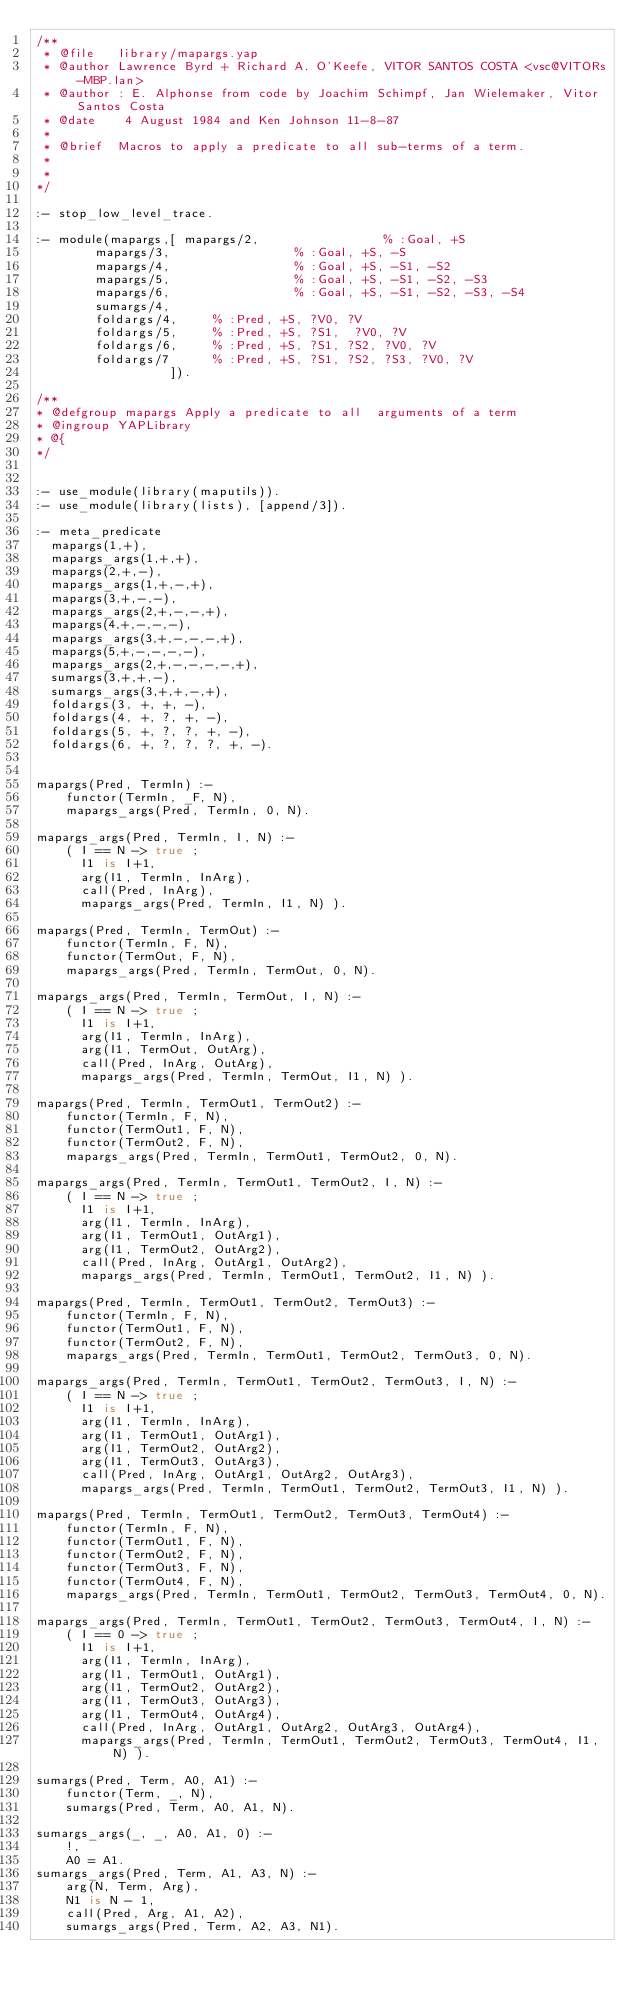Convert code to text. <code><loc_0><loc_0><loc_500><loc_500><_Prolog_>/**
 * @file   library/mapargs.yap
 * @author Lawrence Byrd + Richard A. O'Keefe, VITOR SANTOS COSTA <vsc@VITORs-MBP.lan>
 * @author : E. Alphonse from code by Joachim Schimpf, Jan Wielemaker, Vitor Santos Costa
 * @date    4 August 1984 and Ken Johnson 11-8-87
 *
 * @brief  Macros to apply a predicate to all sub-terms of a term.
 *
 *
*/

:- stop_low_level_trace.

:- module(mapargs,[ mapargs/2,                 % :Goal, +S
		    mapargs/3,                 % :Goal, +S, -S
		    mapargs/4,                 % :Goal, +S, -S1, -S2
		    mapargs/5,                 % :Goal, +S, -S1, -S2, -S3
		    mapargs/6,                 % :Goal, +S, -S1, -S2, -S3, -S4
		    sumargs/4,
		    foldargs/4, 		% :Pred, +S, ?V0, ?V
		    foldargs/5, 		% :Pred, +S, ?S1,  ?V0, ?V
		    foldargs/6, 		% :Pred, +S, ?S1, ?S2, ?V0, ?V
		    foldargs/7	 		% :Pred, +S, ?S1, ?S2, ?S3, ?V0, ?V
                  ]).

/**
* @defgroup mapargs Apply a predicate to all  arguments of a term
* @ingroup YAPLibrary
* @{
*/


:- use_module(library(maputils)).
:- use_module(library(lists), [append/3]).

:- meta_predicate
	mapargs(1,+),
	mapargs_args(1,+,+),
	mapargs(2,+,-),
	mapargs_args(1,+,-,+),
	mapargs(3,+,-,-),
	mapargs_args(2,+,-,-,+),
	mapargs(4,+,-,-,-),
	mapargs_args(3,+,-,-,-,+),
	mapargs(5,+,-,-,-,-),
	mapargs_args(2,+,-,-,-,-,+),
	sumargs(3,+,+,-),
	sumargs_args(3,+,+,-,+),
	foldargs(3, +, +, -),
	foldargs(4, +, ?, +, -),
	foldargs(5, +, ?, ?, +, -),
	foldargs(6, +, ?, ?, ?, +, -).


mapargs(Pred, TermIn) :-
    functor(TermIn, _F, N),
    mapargs_args(Pred, TermIn, 0, N).

mapargs_args(Pred, TermIn, I, N) :-
    ( I == N -> true ;
      I1 is I+1,
      arg(I1, TermIn, InArg),
      call(Pred, InArg),
      mapargs_args(Pred, TermIn, I1, N) ).

mapargs(Pred, TermIn, TermOut) :-
    functor(TermIn, F, N),
    functor(TermOut, F, N),
    mapargs_args(Pred, TermIn, TermOut, 0, N).

mapargs_args(Pred, TermIn, TermOut, I, N) :-
    ( I == N -> true ;
      I1 is I+1,
      arg(I1, TermIn, InArg),
      arg(I1, TermOut, OutArg),
      call(Pred, InArg, OutArg),
      mapargs_args(Pred, TermIn, TermOut, I1, N) ).

mapargs(Pred, TermIn, TermOut1, TermOut2) :-
    functor(TermIn, F, N),
    functor(TermOut1, F, N),
    functor(TermOut2, F, N),
    mapargs_args(Pred, TermIn, TermOut1, TermOut2, 0, N).

mapargs_args(Pred, TermIn, TermOut1, TermOut2, I, N) :-
    ( I == N -> true ;
      I1 is I+1,
      arg(I1, TermIn, InArg),
      arg(I1, TermOut1, OutArg1),
      arg(I1, TermOut2, OutArg2),
      call(Pred, InArg, OutArg1, OutArg2),
      mapargs_args(Pred, TermIn, TermOut1, TermOut2, I1, N) ).

mapargs(Pred, TermIn, TermOut1, TermOut2, TermOut3) :-
    functor(TermIn, F, N),
    functor(TermOut1, F, N),
    functor(TermOut2, F, N),
    mapargs_args(Pred, TermIn, TermOut1, TermOut2, TermOut3, 0, N).

mapargs_args(Pred, TermIn, TermOut1, TermOut2, TermOut3, I, N) :-
    ( I == N -> true ;
      I1 is I+1,
      arg(I1, TermIn, InArg),
      arg(I1, TermOut1, OutArg1),
      arg(I1, TermOut2, OutArg2),
      arg(I1, TermOut3, OutArg3),
      call(Pred, InArg, OutArg1, OutArg2, OutArg3),
      mapargs_args(Pred, TermIn, TermOut1, TermOut2, TermOut3, I1, N) ).

mapargs(Pred, TermIn, TermOut1, TermOut2, TermOut3, TermOut4) :-
    functor(TermIn, F, N),
    functor(TermOut1, F, N),
    functor(TermOut2, F, N),
    functor(TermOut3, F, N),
    functor(TermOut4, F, N),
    mapargs_args(Pred, TermIn, TermOut1, TermOut2, TermOut3, TermOut4, 0, N).

mapargs_args(Pred, TermIn, TermOut1, TermOut2, TermOut3, TermOut4, I, N) :-
    ( I == 0 -> true ;
      I1 is I+1,
      arg(I1, TermIn, InArg),
      arg(I1, TermOut1, OutArg1),
      arg(I1, TermOut2, OutArg2),
      arg(I1, TermOut3, OutArg3),
      arg(I1, TermOut4, OutArg4),
      call(Pred, InArg, OutArg1, OutArg2, OutArg3, OutArg4),
      mapargs_args(Pred, TermIn, TermOut1, TermOut2, TermOut3, TermOut4, I1, N) ).

sumargs(Pred, Term, A0, A1) :-
    functor(Term, _, N),
    sumargs(Pred, Term, A0, A1, N).

sumargs_args(_, _, A0, A1, 0) :-
    !,
    A0 = A1.
sumargs_args(Pred, Term, A1, A3, N) :-
    arg(N, Term, Arg),
    N1 is N - 1,
    call(Pred, Arg, A1, A2),
    sumargs_args(Pred, Term, A2, A3, N1).

</code> 